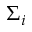Convert formula to latex. <formula><loc_0><loc_0><loc_500><loc_500>\Sigma _ { i }</formula> 